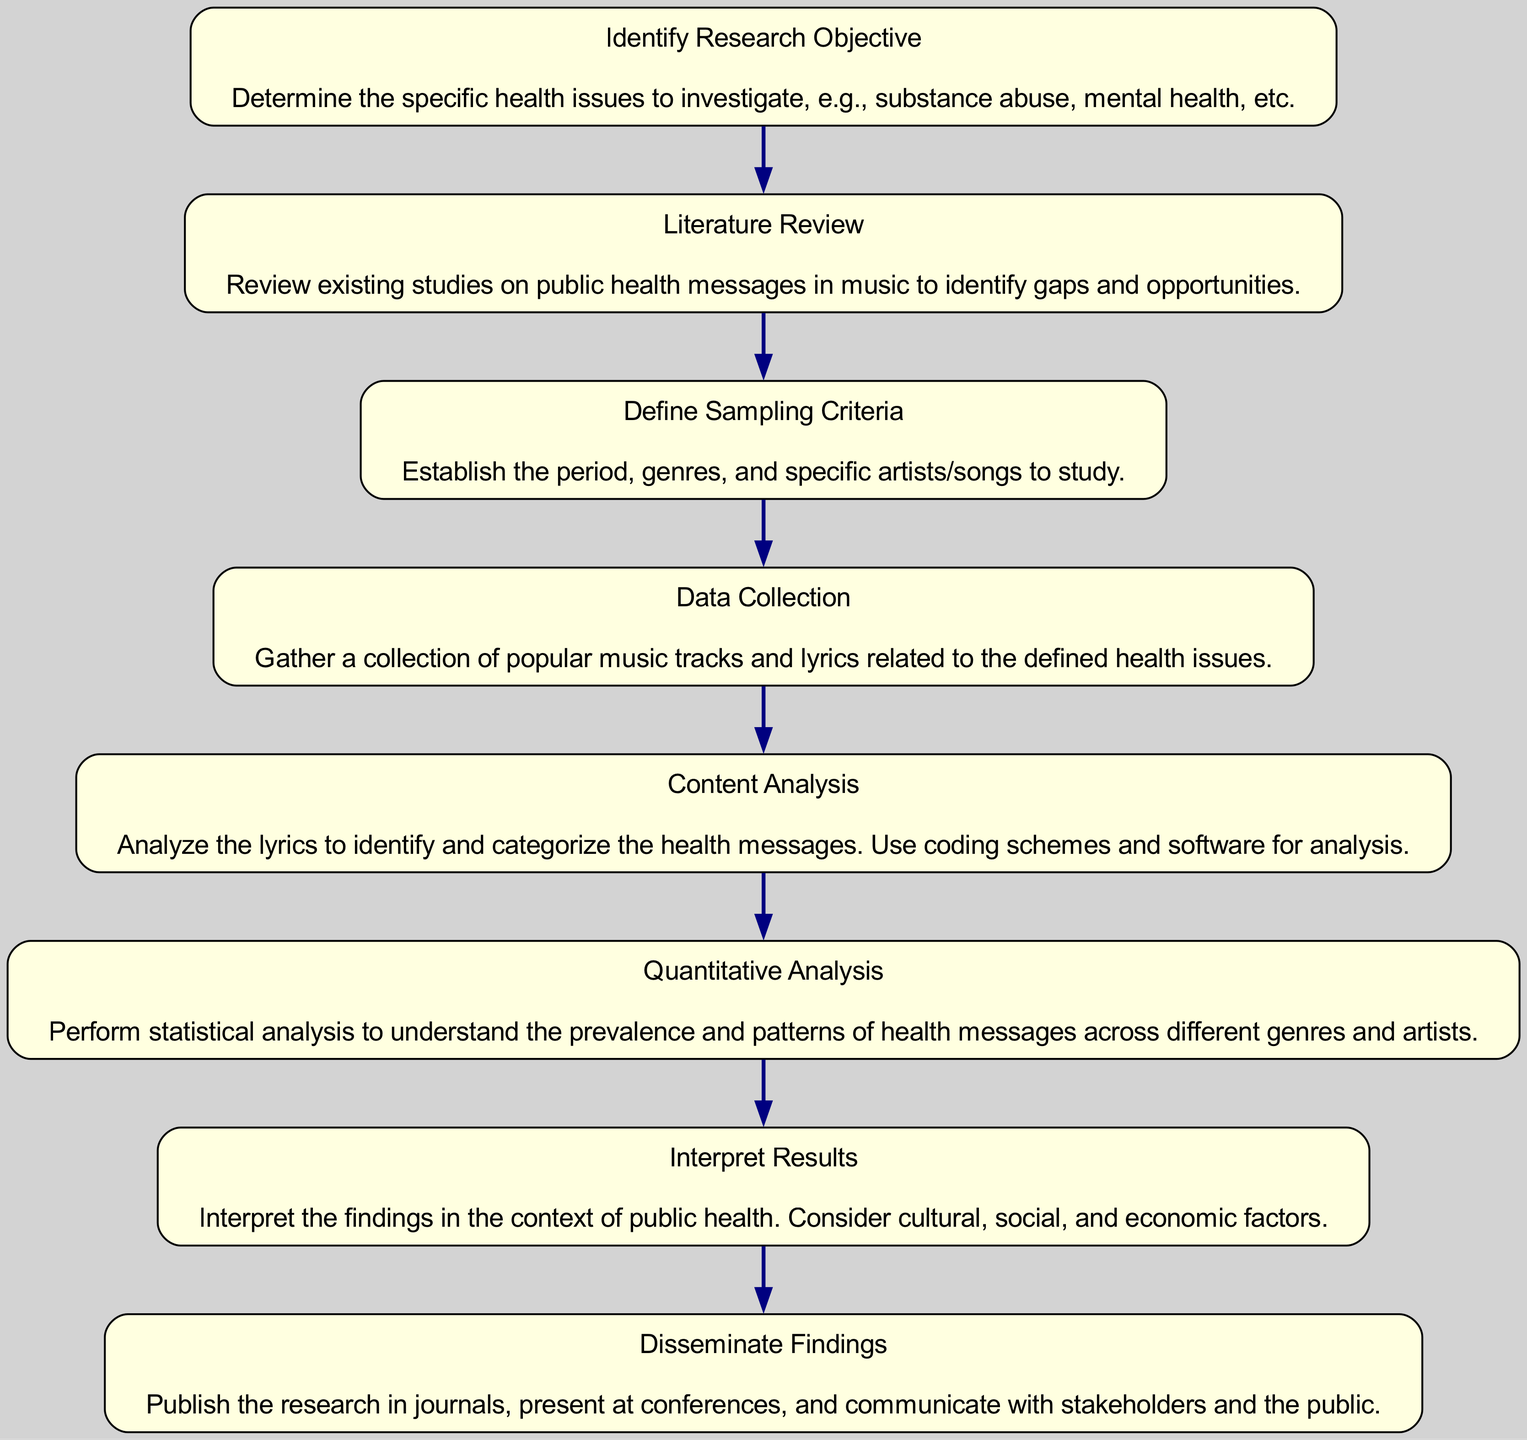What is the first step in the research process? The diagram indicates the first step is to "Identify Research Objective." This is the initial action that initiates the research study on public health messages in popular music.
Answer: Identify Research Objective How many steps are in the research flow chart? By counting the nodes in the diagram, there are a total of eight steps listed in the research process. Each step corresponds to a distinct stage in the research study.
Answer: Eight What follows after "Data Collection"? According to the flow chart, the step that follows "Data Collection" is "Content Analysis." This shows the sequential process from collecting data to analyzing it.
Answer: Content Analysis Which step involves gathering music tracks and lyrics? The diagram specifies that "Data Collection" is the step focused on gathering popular music tracks and lyrics related to the defined health issues.
Answer: Data Collection What are the last two steps in the research study flow? The last two steps, according to the flow chart, are "Interpret Results" and "Disseminate Findings." These steps indicate the conclusion and communication of the research outcomes.
Answer: Interpret Results and Disseminate Findings What type of analysis is performed after content analysis? The flow chart indicates that "Quantitative Analysis" is performed after content analysis. This step involves statistical analysis following the coding and categorization of health messages.
Answer: Quantitative Analysis In which step are existing studies reviewed? The diagram shows that the step where existing studies are reviewed is "Literature Review." This step identifies any existing gaps in public health messages in music.
Answer: Literature Review How does the study interpret its findings? According to the flow chart, the step titled "Interpret Results" demonstrates that findings are interpreted in the context of public health, considering cultural, social, and economic factors.
Answer: Interpret Results 